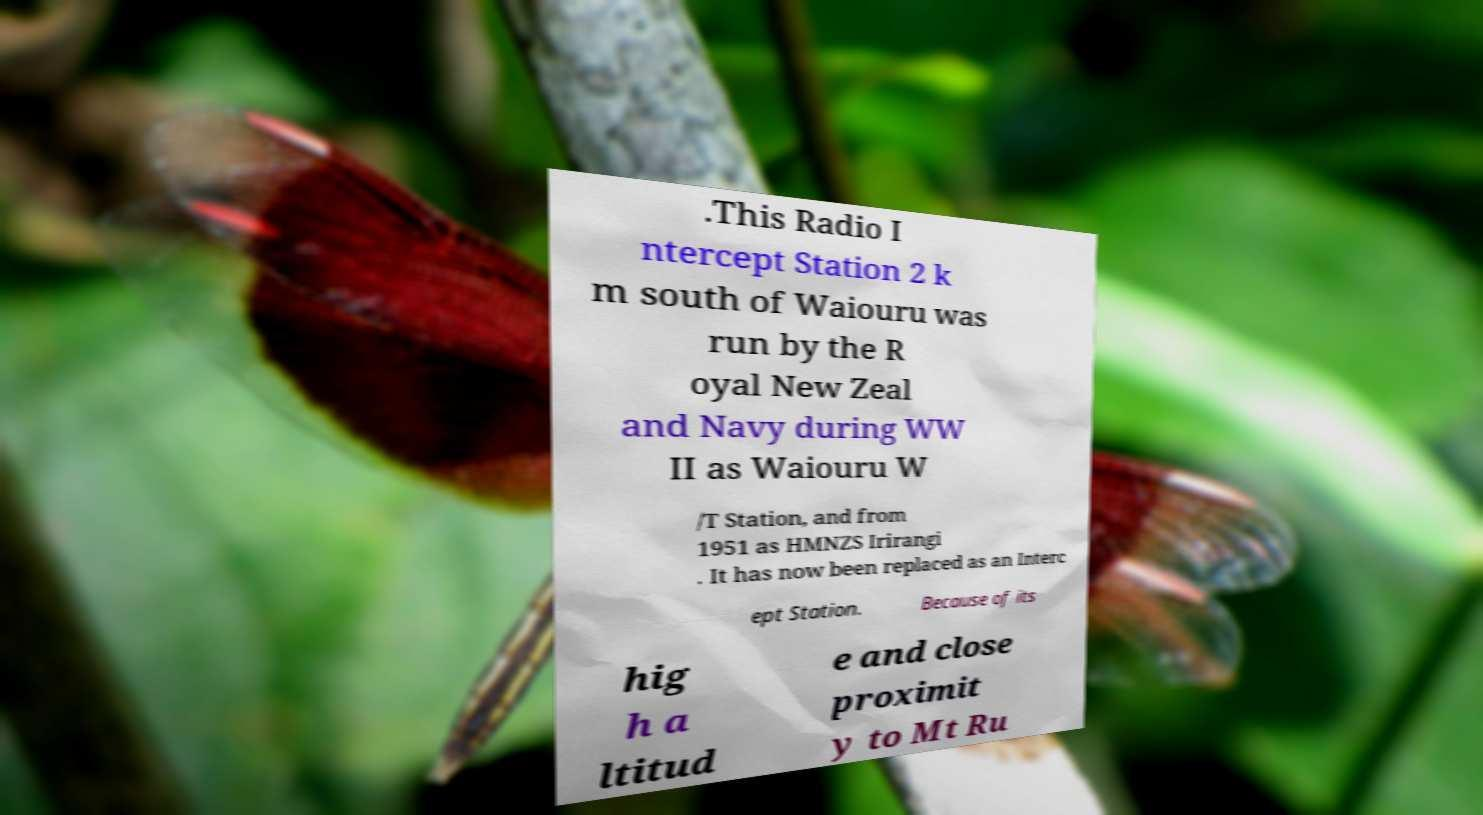Please identify and transcribe the text found in this image. .This Radio I ntercept Station 2 k m south of Waiouru was run by the R oyal New Zeal and Navy during WW II as Waiouru W /T Station, and from 1951 as HMNZS Irirangi . It has now been replaced as an Interc ept Station. Because of its hig h a ltitud e and close proximit y to Mt Ru 